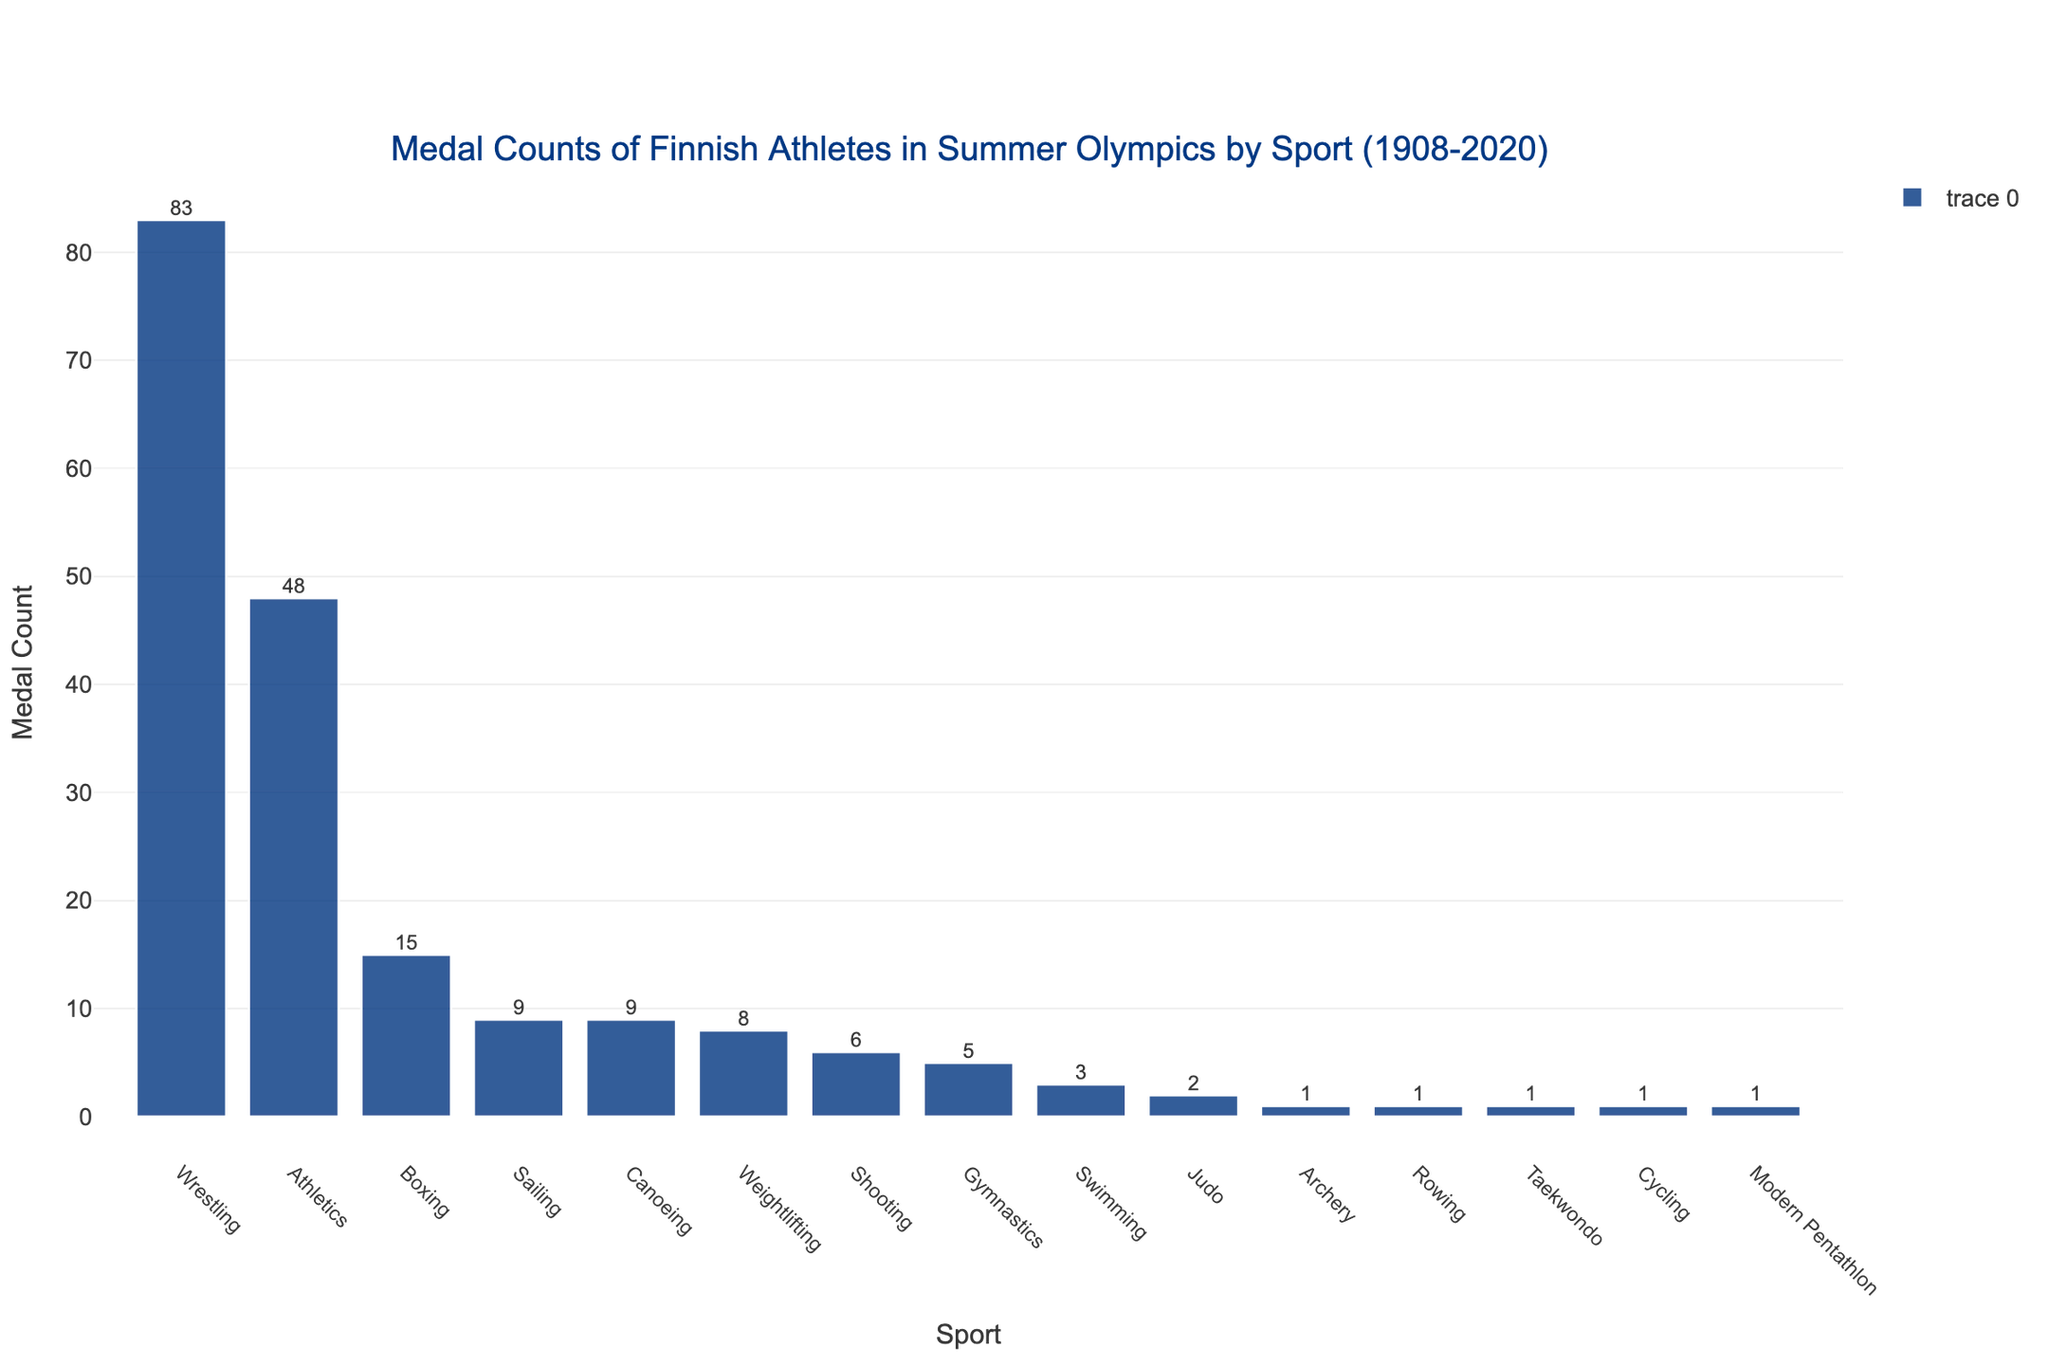Which sport has the highest medal count? Locate the tallest bar in the bar chart, which represents the sport with the highest count. The "Wrestling" bar is the tallest.
Answer: Wrestling What is the sum of medal counts for Boxing and Weightlifting? Find the medal counts for each sport: Boxing has 15 and Weightlifting has 8. Add them together: 15 + 8 = 23.
Answer: 23 Which sport has a higher medal count: Sailing or Canoeing? Compare the heights of the bars for Sailing and Canoeing. Sailing has a count of 9, while Canoeing also has a count of 9. Therefore, both have equal counts.
Answer: Both are equal How many sports have a medal count of 1? Identify the bars that have a height corresponding to the value 1. There are four such sports: Archery, Rowing, Taekwondo, and Cycling.
Answer: 4 What is the difference in medal count between Athletics and Gymnastics? Find the medal counts for each sport: Athletics has 48 and Gymnastics has 5. Subtract Gymnastics from Athletics: 48 - 5 = 43.
Answer: 43 Which sport appears last in the sorted order of medal counts? Identify the bar at the far right of the chart, which represents the sport with the lowest medal count. This is "Modern Pentathlon."
Answer: Modern Pentathlon Which sport shows a medal count closest to the median medal count of all sports? First, list the medal counts in ascending order: 1, 1, 1, 1, 2, 3, 5, 6, 8, 9, 9, 15, 48, 83. Because there are 15 sports, the median is the 8th value: 6, which corresponds to Shooting.
Answer: Shooting What is the combined medal count for all sports that have more than 10 medals? Identify the sports with more than 10 medals: Wrestling (83), Athletics (48), and Boxing (15). Sum their counts: 83 + 48 + 15 = 146.
Answer: 146 Are there any sports with exactly 6 medals? If so, which one(s)? Look for a bar with a height that corresponds to the value 6. This is "Shooting."
Answer: Shooting Which sports have fewer than 5 medals? Identify the bars representing sports with heights less than 5. These are Judo (2), Archery (1), Rowing (1), Taekwondo (1), Cycling (1), and Modern Pentathlon (1).
Answer: Judo, Archery, Rowing, Taekwondo, Cycling, Modern Pentathlon 